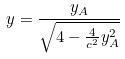<formula> <loc_0><loc_0><loc_500><loc_500>y = \frac { y _ { A } } { \sqrt { 4 - \frac { 4 } { c ^ { 2 } } y _ { A } ^ { 2 } } }</formula> 